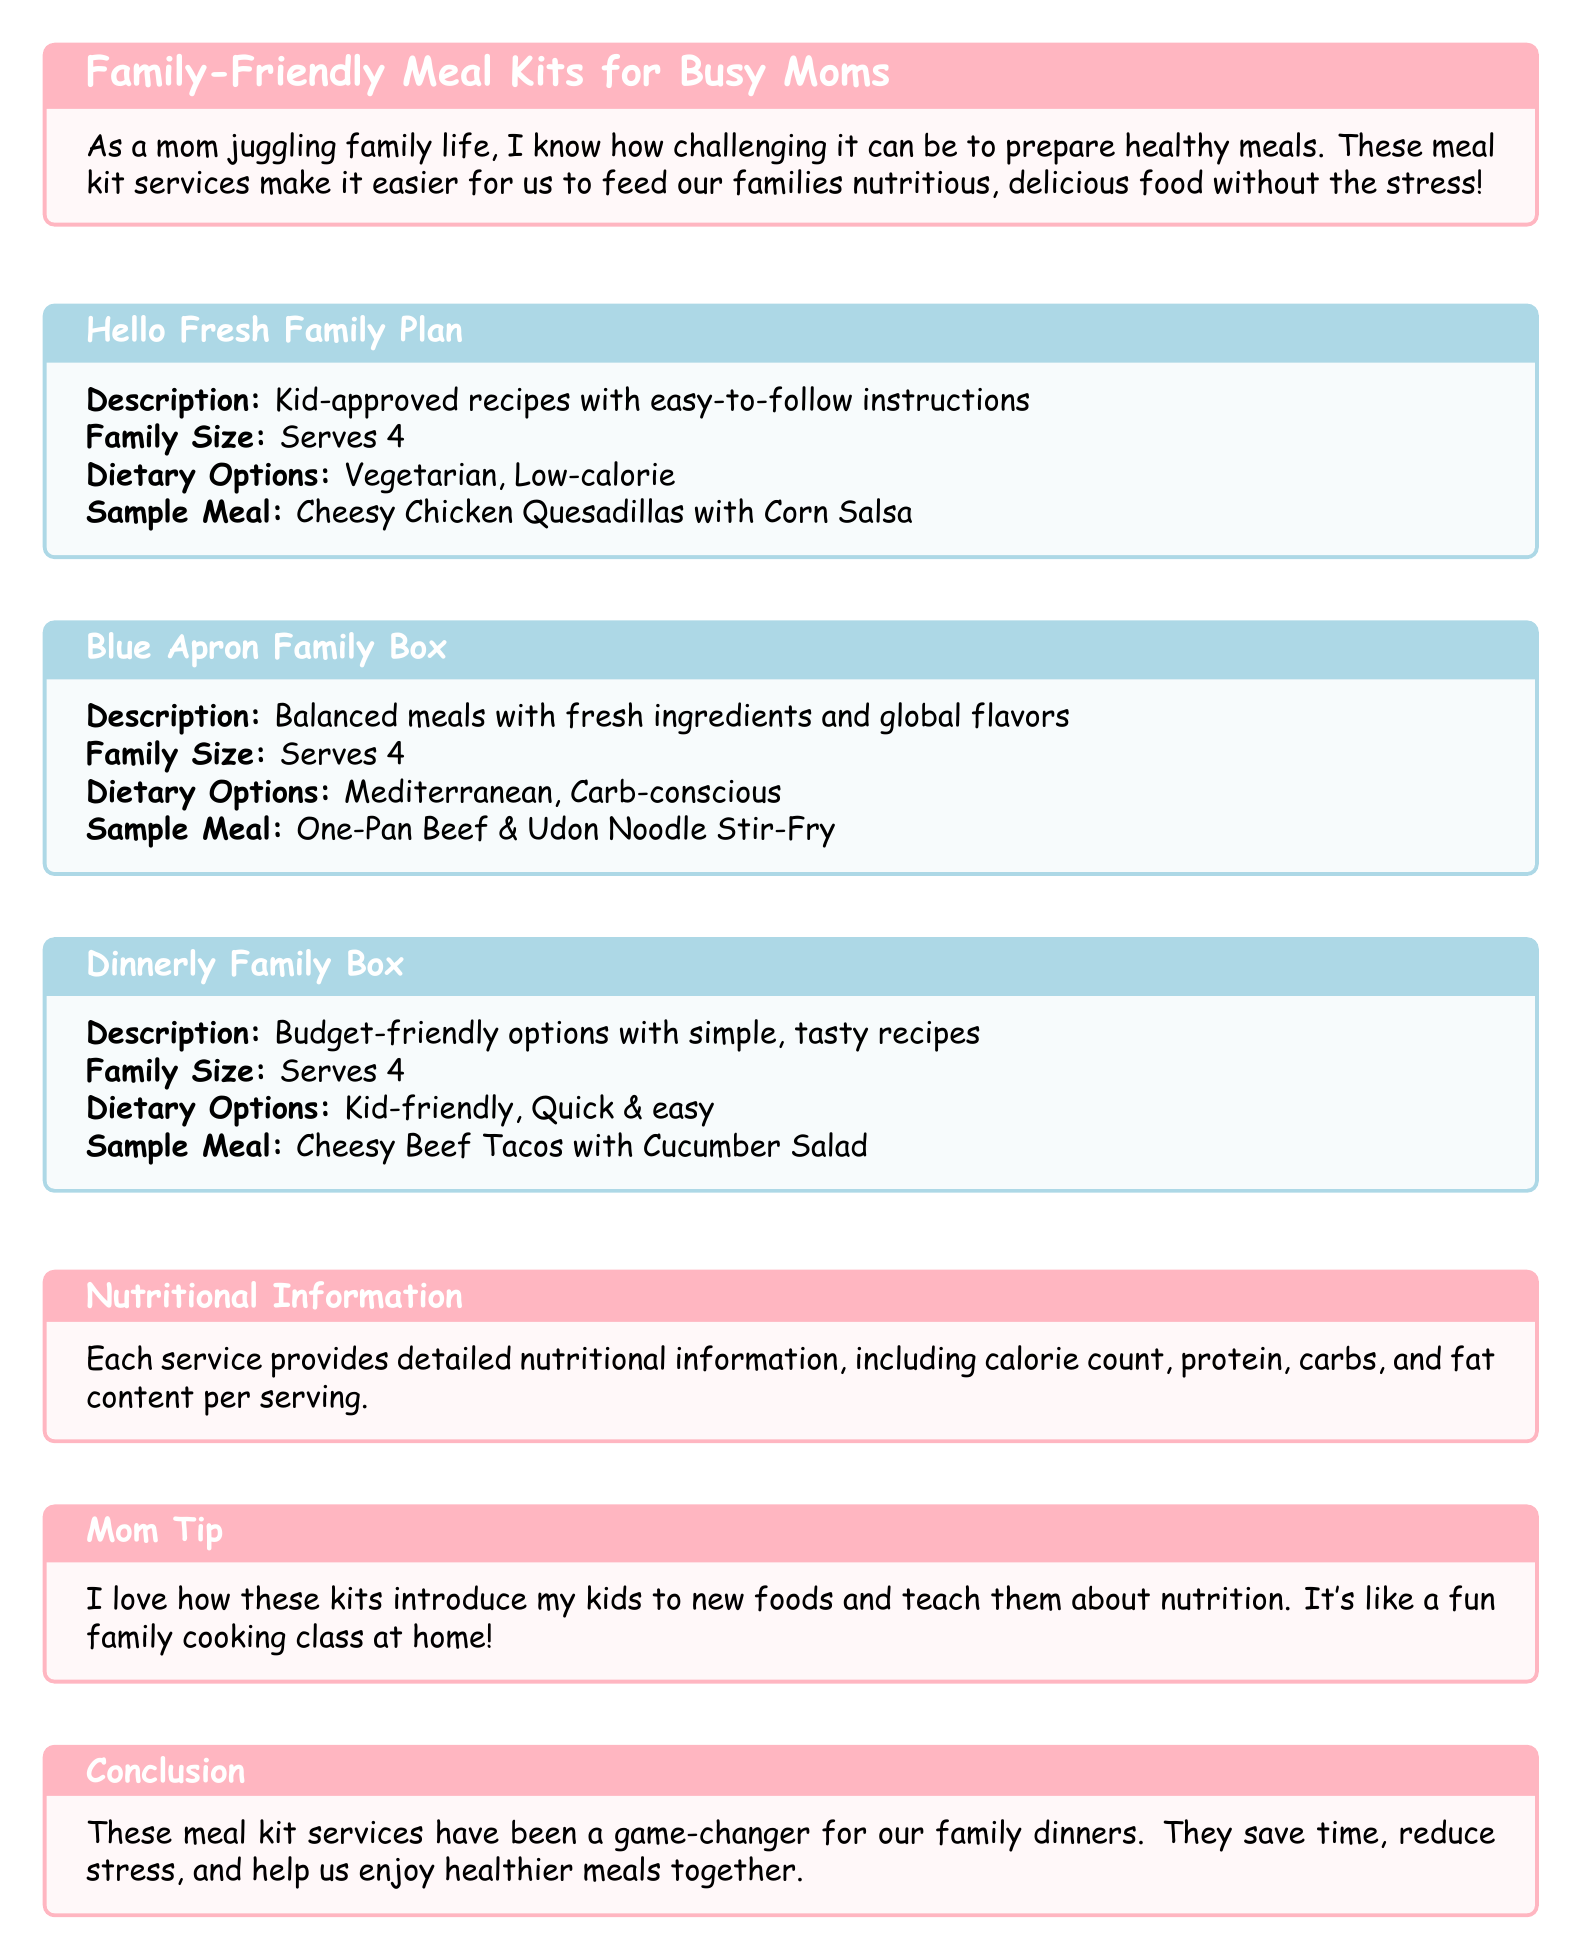what is the family size for Hello Fresh Family Plan? The family size for Hello Fresh Family Plan is 4.
Answer: 4 what is a sample meal from Blue Apron Family Box? A sample meal from Blue Apron Family Box is One-Pan Beef & Udon Noodle Stir-Fry.
Answer: One-Pan Beef & Udon Noodle Stir-Fry which dietary options are available for Dinnerly Family Box? The dietary options available for Dinnerly Family Box are Kid-friendly and Quick & easy.
Answer: Kid-friendly, Quick & easy what kind of recipes does Hello Fresh Family Plan offer? Hello Fresh Family Plan offers kid-approved recipes.
Answer: kid-approved recipes how does the catalog suggest the meal kits help families? The catalog suggests that meal kits save time, reduce stress, and help enjoy healthier meals together.
Answer: save time, reduce stress, help enjoy healthier meals together what is the color used for the Family-Friendly Meal Kits section? The color used for the Family-Friendly Meal Kits section is momypink.
Answer: momypink what is the purpose of the Nutritional Information section? The purpose of the Nutritional Information section is to provide detailed nutritional information per serving.
Answer: provide detailed nutritional information per serving what is a notable benefit of using these meal kits according to the Mom Tip? A notable benefit is that they introduce kids to new foods and teach them about nutrition.
Answer: introduce kids to new foods, teach them about nutrition 